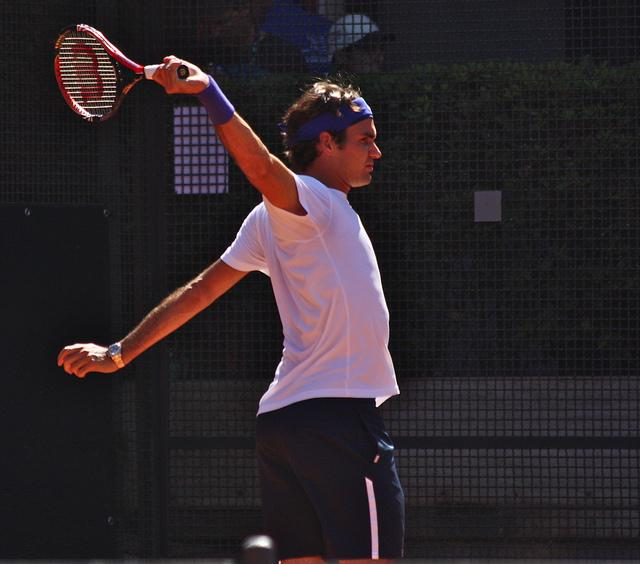What is the silver object on the man's wrist used for?

Choices:
A) telling time
B) covering cut
C) preventing sweat
D) tracking steps telling time 